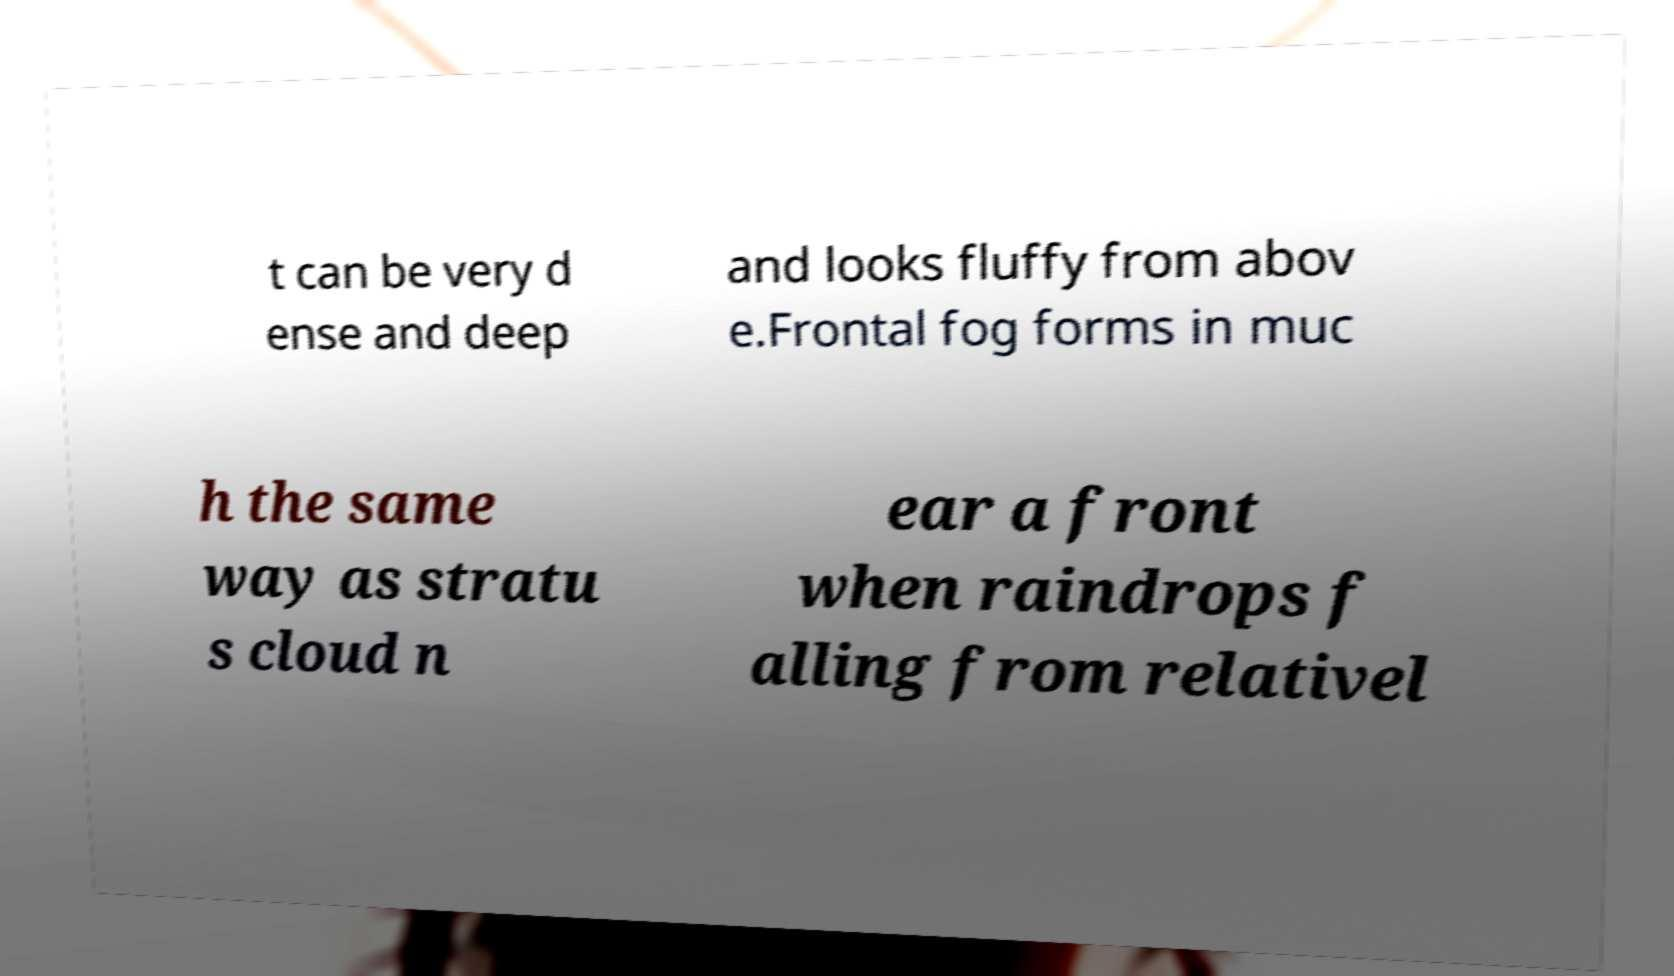There's text embedded in this image that I need extracted. Can you transcribe it verbatim? t can be very d ense and deep and looks fluffy from abov e.Frontal fog forms in muc h the same way as stratu s cloud n ear a front when raindrops f alling from relativel 